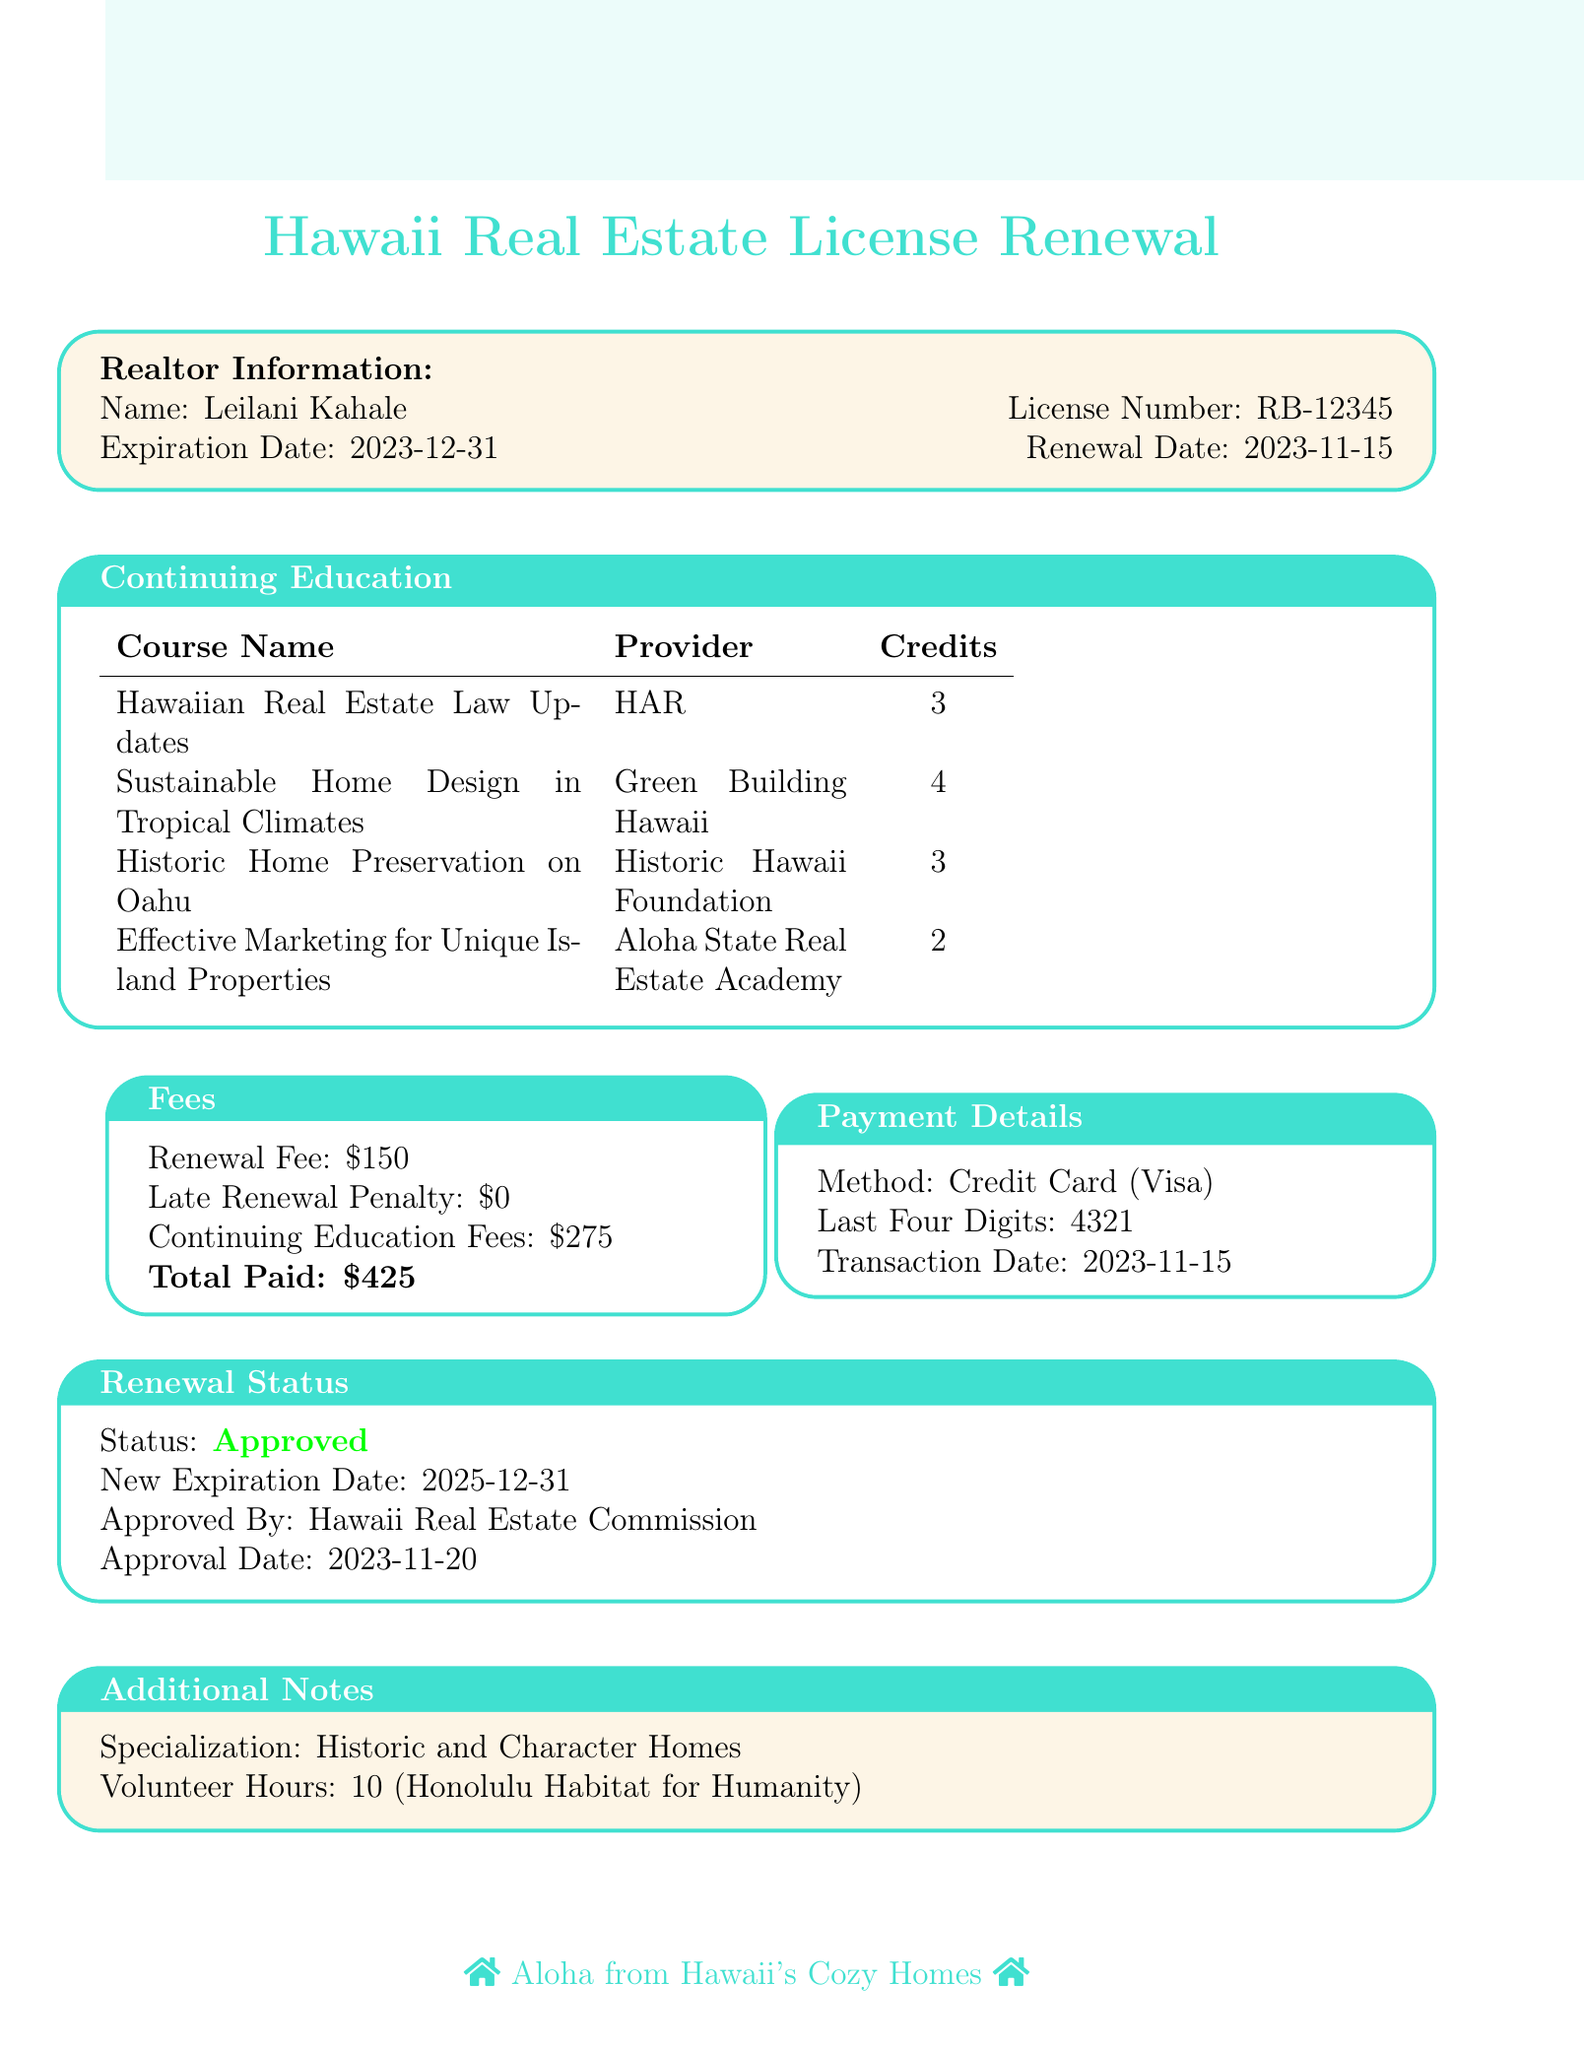What is the name of the realtor? The document specifies the name of the realtor as Leilani Kahale.
Answer: Leilani Kahale What is the renewal fee? The renewal fee listed in the document is specifically stated as $150.
Answer: $150 How many continuing education credits were earned? The total number of continuing education credits from the courses detailed amounts to 12 credits (3 + 4 + 3 + 2).
Answer: 12 What is the new expiration date of the license? The new expiration date after renewal is mentioned as December 31, 2025.
Answer: 2025-12-31 What courses are included in the continuing education? The courses listed are Hawaiian Real Estate Law Updates, Sustainable Home Design in Tropical Climates, Historic Home Preservation on Oahu, and Effective Marketing for Unique Island Properties.
Answer: Hawaiian Real Estate Law Updates, Sustainable Home Design in Tropical Climates, Historic Home Preservation on Oahu, Effective Marketing for Unique Island Properties What is the total amount paid for renewal? The total amount paid for the renewal of the license is stated clearly in the fees section as $425.
Answer: $425 Who approved the renewal? The approval for the renewal was given by the Hawaii Real Estate Commission as stated in the renewal status.
Answer: Hawaii Real Estate Commission What specialization does the realtor have? The document notes the realtor's specialization as Historic and Character Homes.
Answer: Historic and Character Homes How many volunteer hours were completed? According to the additional notes, the total volunteer hours documented are 10.
Answer: 10 